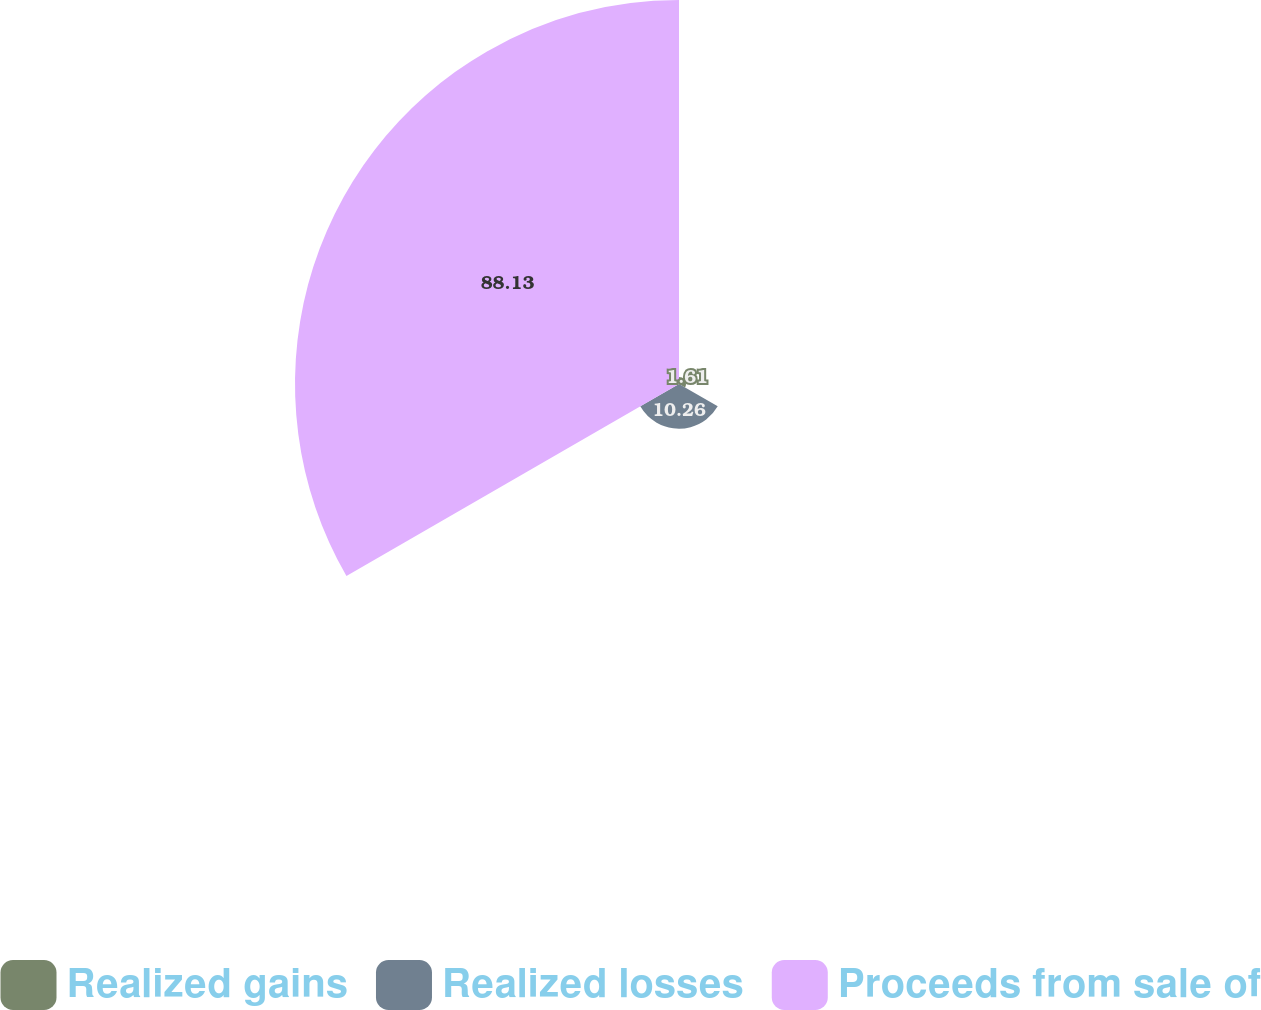Convert chart to OTSL. <chart><loc_0><loc_0><loc_500><loc_500><pie_chart><fcel>Realized gains<fcel>Realized losses<fcel>Proceeds from sale of<nl><fcel>1.61%<fcel>10.26%<fcel>88.12%<nl></chart> 